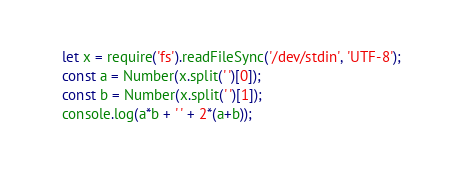<code> <loc_0><loc_0><loc_500><loc_500><_JavaScript_>let x = require('fs').readFileSync('/dev/stdin', 'UTF-8');
const a = Number(x.split(' ')[0]);
const b = Number(x.split(' ')[1]);
console.log(a*b + ' ' + 2*(a+b));
</code> 